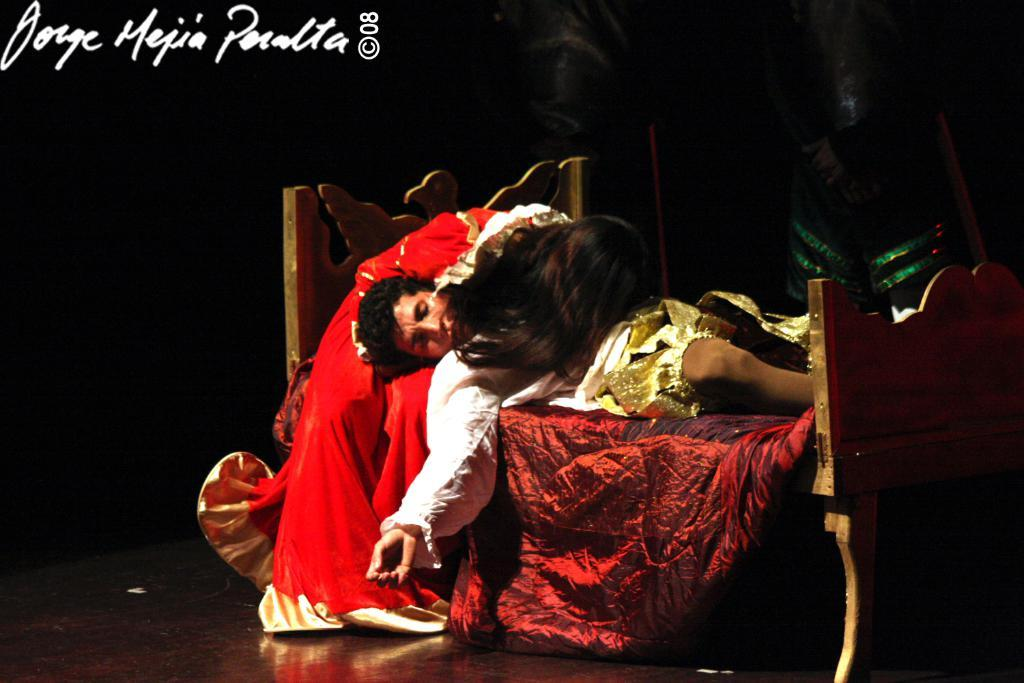What is the main object in the center of the image? There is a bed in the center of the image. What are the people on the bed doing? The people are wearing costumes and lying on the bed. Can you describe the cloth in the image? Yes, there is a cloth in the image. What else can be seen in the background of the image? There is a person standing in the background of the image. What type of bell can be heard ringing in the image? There is no bell present in the image, and therefore no sound can be heard. 